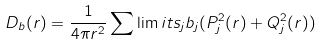Convert formula to latex. <formula><loc_0><loc_0><loc_500><loc_500>D _ { b } ( r ) = \frac { 1 } { 4 \pi r ^ { 2 } } \sum \lim i t s _ { j } b _ { j } ( P _ { j } ^ { 2 } ( r ) + Q _ { j } ^ { 2 } ( r ) )</formula> 